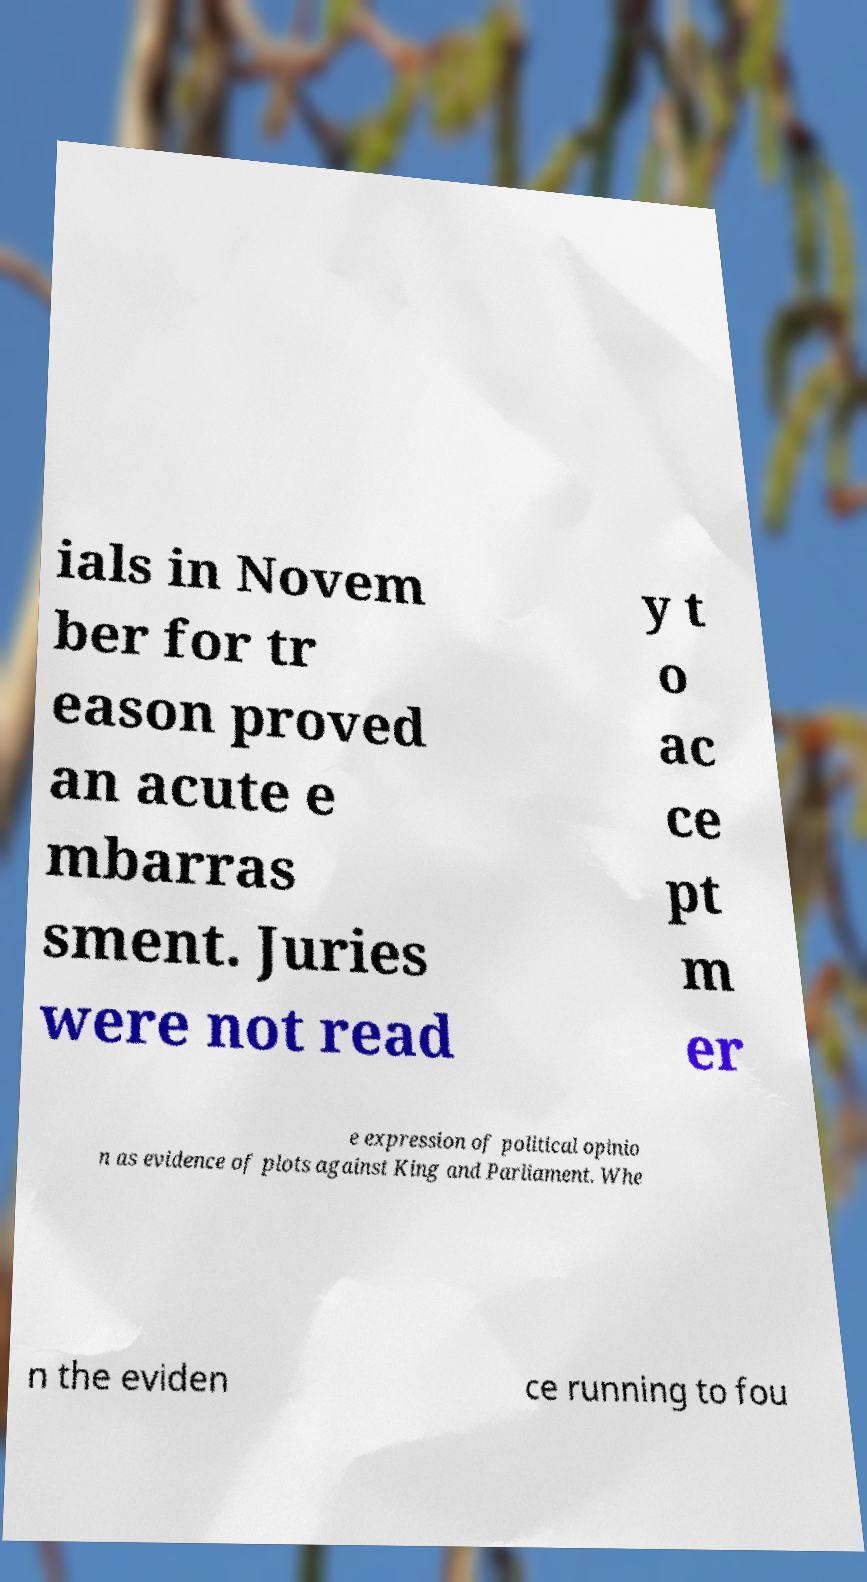What messages or text are displayed in this image? I need them in a readable, typed format. ials in Novem ber for tr eason proved an acute e mbarras sment. Juries were not read y t o ac ce pt m er e expression of political opinio n as evidence of plots against King and Parliament. Whe n the eviden ce running to fou 